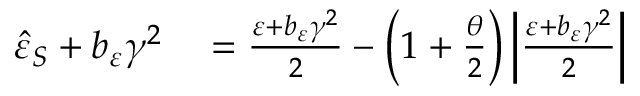Convert formula to latex. <formula><loc_0><loc_0><loc_500><loc_500>\begin{array} { r l } { \hat { \varepsilon } _ { S } + b _ { \varepsilon } \gamma ^ { 2 } } & = \frac { \varepsilon + b _ { \varepsilon } \gamma ^ { 2 } } { 2 } - \left ( 1 + \frac { \theta } { 2 } \right ) \left | \frac { \varepsilon + b _ { \varepsilon } \gamma ^ { 2 } } { 2 } \right | } \end{array}</formula> 